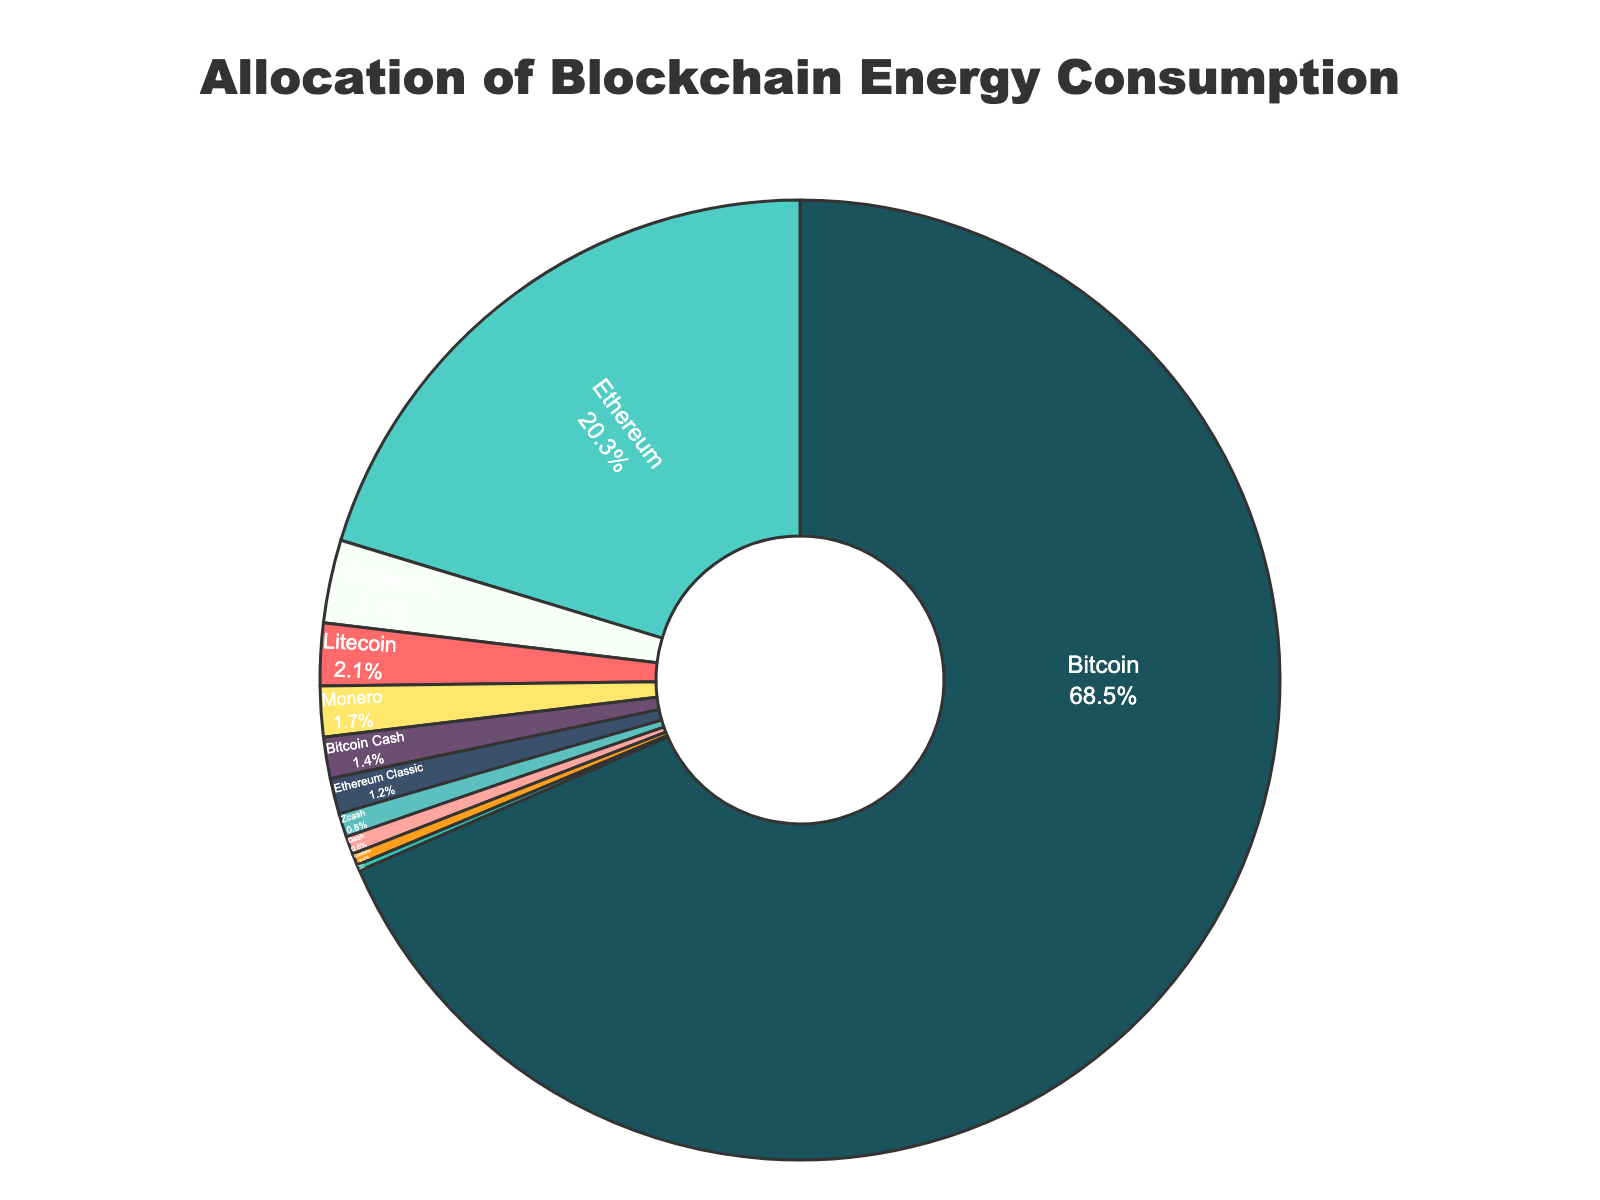Which cryptocurrency has the highest energy consumption percentage? Bitcoin has the highest energy consumption percentage as shown by the largest section of the pie chart distinctly labeled with 68.5%.
Answer: Bitcoin Which cryptocurrency consumes the least amount of energy? Tezos consumes the least amount of energy, shown by the smallest slice of the pie chart with the value of 0.2%.
Answer: Tezos What is the combined energy consumption percentage of Dogecoin, Litecoin, and Monero? Dogecoin, Litecoin, and Monero have energy consumption percentages of 2.8%, 2.1%, and 1.7%, respectively. Adding these gives 2.8 + 2.1 + 1.7 = 6.6%.
Answer: 6.6% How does the energy consumption of Ethereum compare to Bitcoin Cash and Zcash combined? Ethereum has an energy consumption percentage of 20.3%. Bitcoin Cash and Zcash combined equal 1.4% + 0.8% = 2.2%. Thus, Ethereum consumes significantly more energy than Bitcoin Cash and Zcash combined.
Answer: Ethereum consumes more What proportion of the total energy consumption is represented by cryptocurrencies other than Bitcoin and Ethereum? The total energy consumption of cryptocurrencies other than Bitcoin and Ethereum is the sum of their percentages: 2.8% + 2.1% + 1.7% + 1.4% + 1.2% + 0.8% + 0.6% + 0.4% + 0.2% = 11.2%.
Answer: 11.2% How does Dogecoin's energy consumption compare to Litecoin's? Dogecoin consumes 2.8% of energy while Litecoin consumes 2.1%. Dogecoin has a higher energy consumption percentage than Litecoin.
Answer: Dogecoin has higher consumption Which segment color represents Bitcoin, and how can you tell its significance in the chart? Bitcoin is represented by the dark teal color (#1a535c). It has the largest segment, indicating its significant energy consumption compared to other cryptocurrencies.
Answer: dark teal Which cryptocurrency has almost the same energy consumption as Monero? Bitcoin Cash has a similar energy consumption percentage to Monero, with 1.4% compared to Monero's 1.7%. Both are relatively small slices close in size.
Answer: Bitcoin Cash 